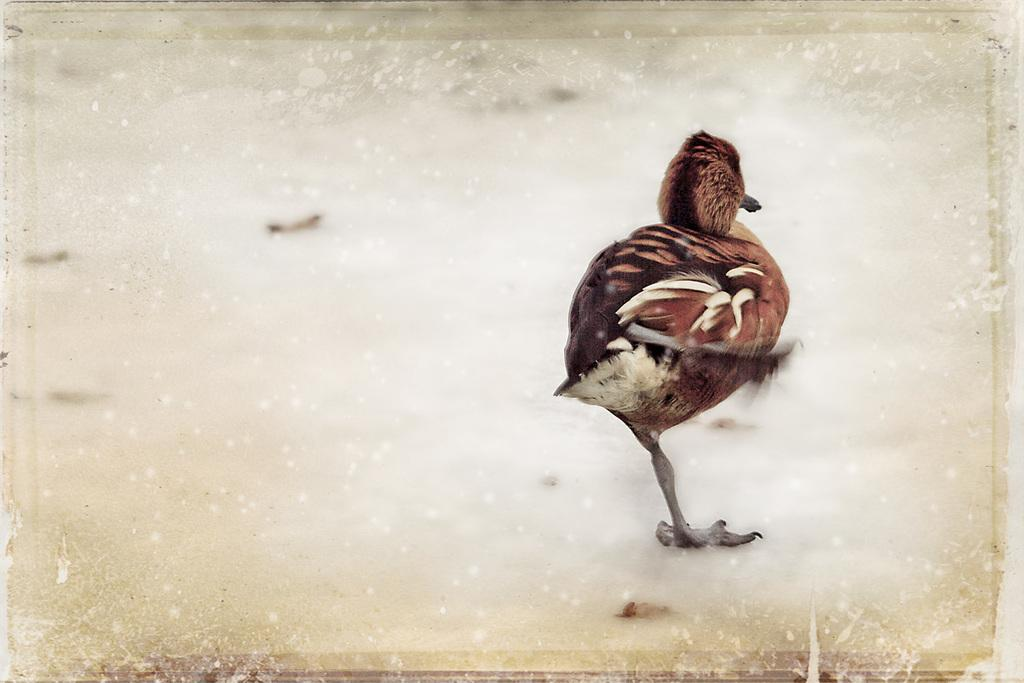What type of animal can be seen in the image? There is a bird in the image. What is the primary surface visible in the image? The ground is visible in the image. How does the bird push the crowd in the image? There is no crowd present in the image, and the bird is not shown pushing anything. 